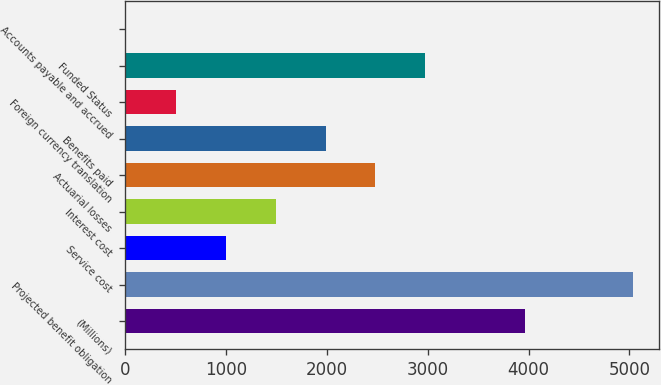Convert chart. <chart><loc_0><loc_0><loc_500><loc_500><bar_chart><fcel>(Millions)<fcel>Projected benefit obligation<fcel>Service cost<fcel>Interest cost<fcel>Actuarial losses<fcel>Benefits paid<fcel>Foreign currency translation<fcel>Funded Status<fcel>Accounts payable and accrued<nl><fcel>3964.2<fcel>5038.9<fcel>1000.8<fcel>1494.7<fcel>2482.5<fcel>1988.6<fcel>506.9<fcel>2976.4<fcel>13<nl></chart> 